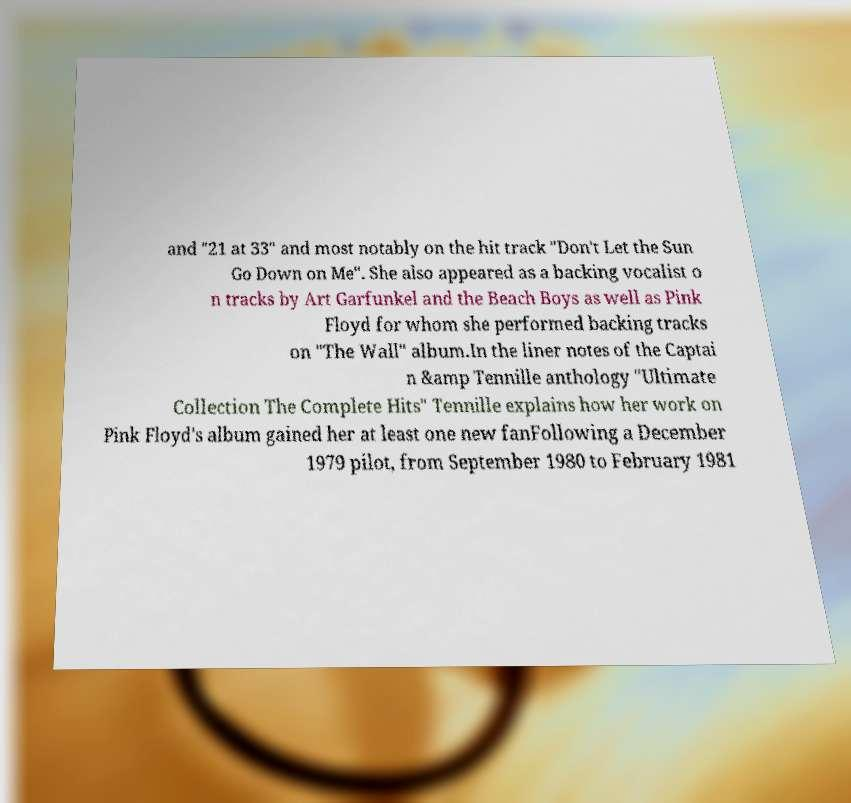I need the written content from this picture converted into text. Can you do that? and "21 at 33" and most notably on the hit track "Don't Let the Sun Go Down on Me". She also appeared as a backing vocalist o n tracks by Art Garfunkel and the Beach Boys as well as Pink Floyd for whom she performed backing tracks on "The Wall" album.In the liner notes of the Captai n &amp Tennille anthology "Ultimate Collection The Complete Hits" Tennille explains how her work on Pink Floyd's album gained her at least one new fanFollowing a December 1979 pilot, from September 1980 to February 1981 